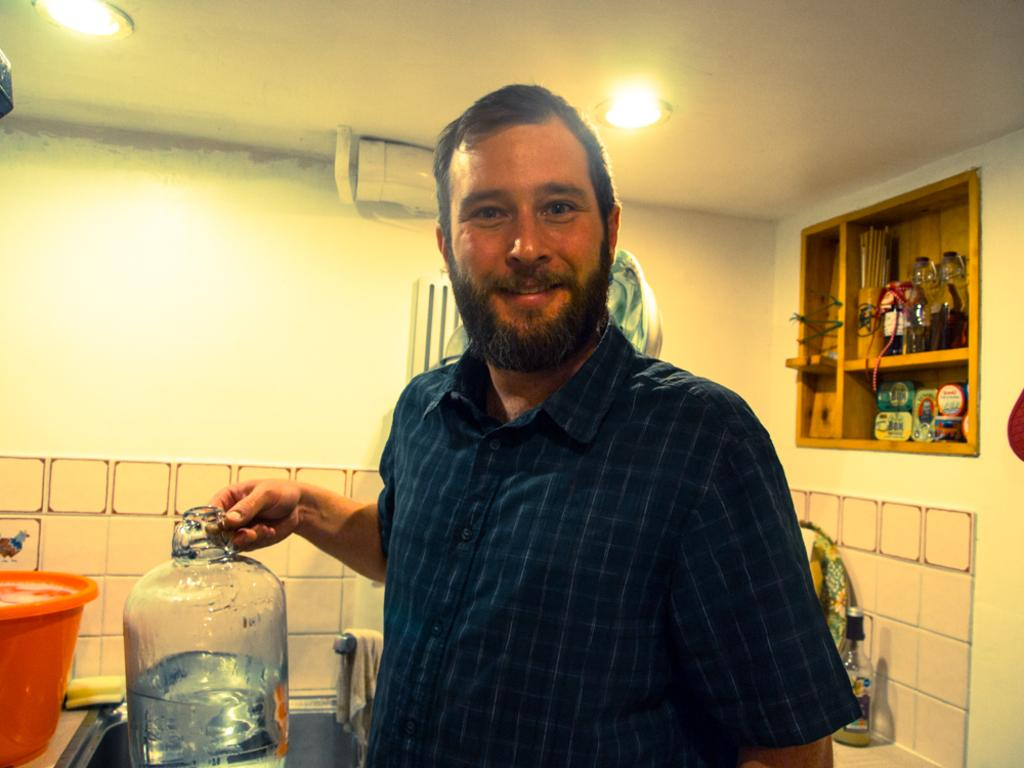What is the main subject of the image? There is a person in the image. What objects can be seen in the image? There is a container, a water can, a rack, lights, a bottle, a sink, a cloth, and a tap in the image. Are there any objects on a rock in the image? Yes, there are objects on a rock in the image. What is the purpose of the water can in the image? The water can is likely used for watering plants or other purposes. What is the function of the tap in the image? The tap is used to control the flow of water from the sink. What type of fuel is being used in the lunchroom depicted in the image? There is no lunchroom depicted in the image, and therefore no fuel usage can be observed. What impulse caused the person to create the objects on the rock in the image? The image does not provide information about the person's motivation or impulse for creating the objects on the rock. 